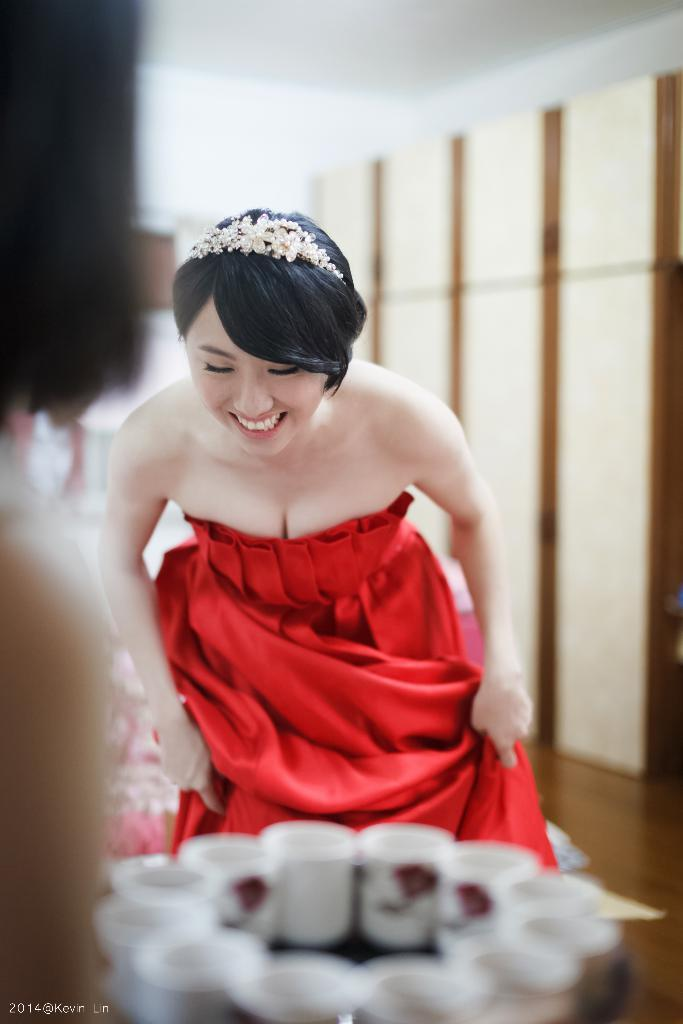What is the main subject of the image? There is a person in the image. What can be seen on an object in the image? There are glasses on an object in the image. Can you describe the background of the image? There is a person standing in the background, along with cupboards and a wall. What type of cap is the insect wearing in the image? There is no insect or cap present in the image. What song is being sung by the person in the image? The image does not provide any information about a song being sung by the person. 